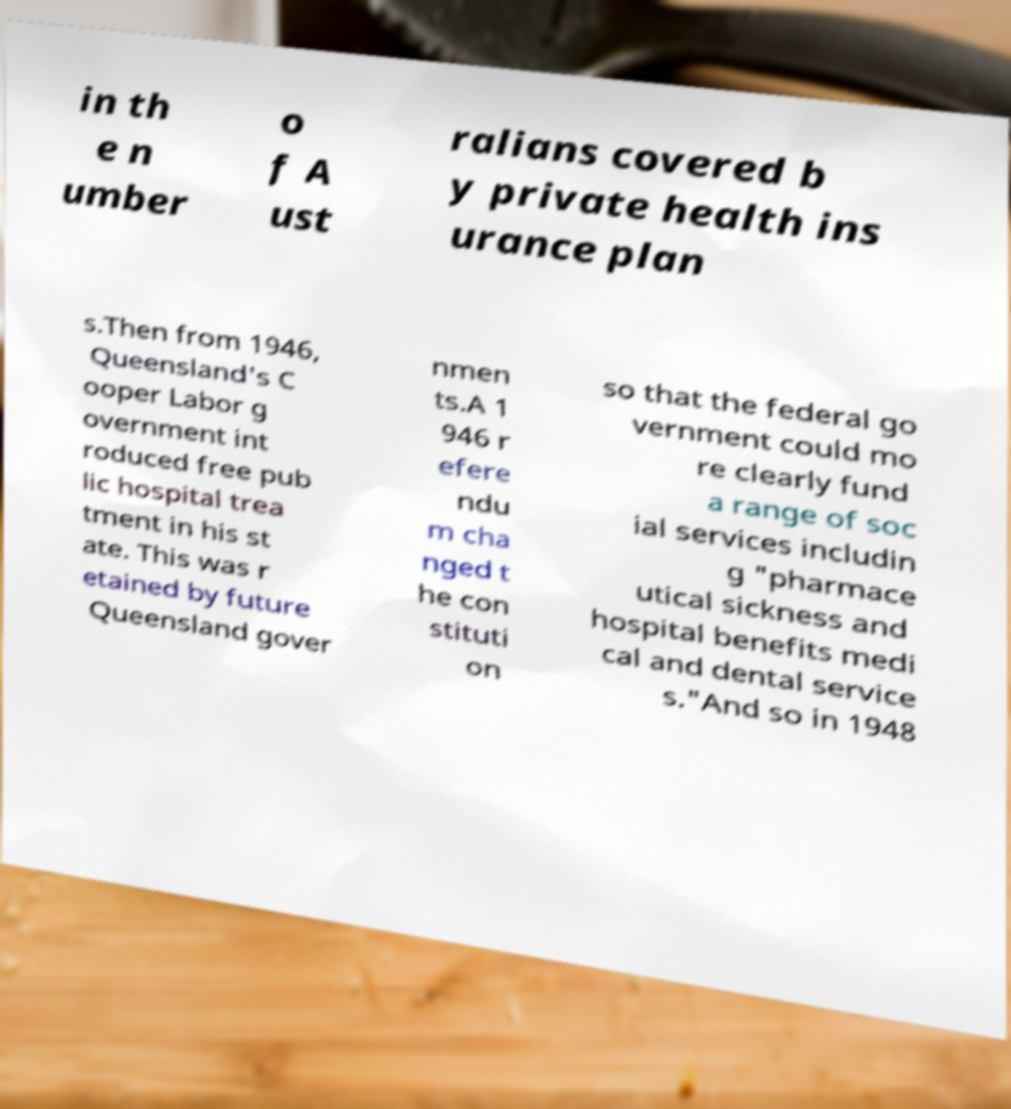Can you accurately transcribe the text from the provided image for me? in th e n umber o f A ust ralians covered b y private health ins urance plan s.Then from 1946, Queensland's C ooper Labor g overnment int roduced free pub lic hospital trea tment in his st ate. This was r etained by future Queensland gover nmen ts.A 1 946 r efere ndu m cha nged t he con stituti on so that the federal go vernment could mo re clearly fund a range of soc ial services includin g "pharmace utical sickness and hospital benefits medi cal and dental service s."And so in 1948 